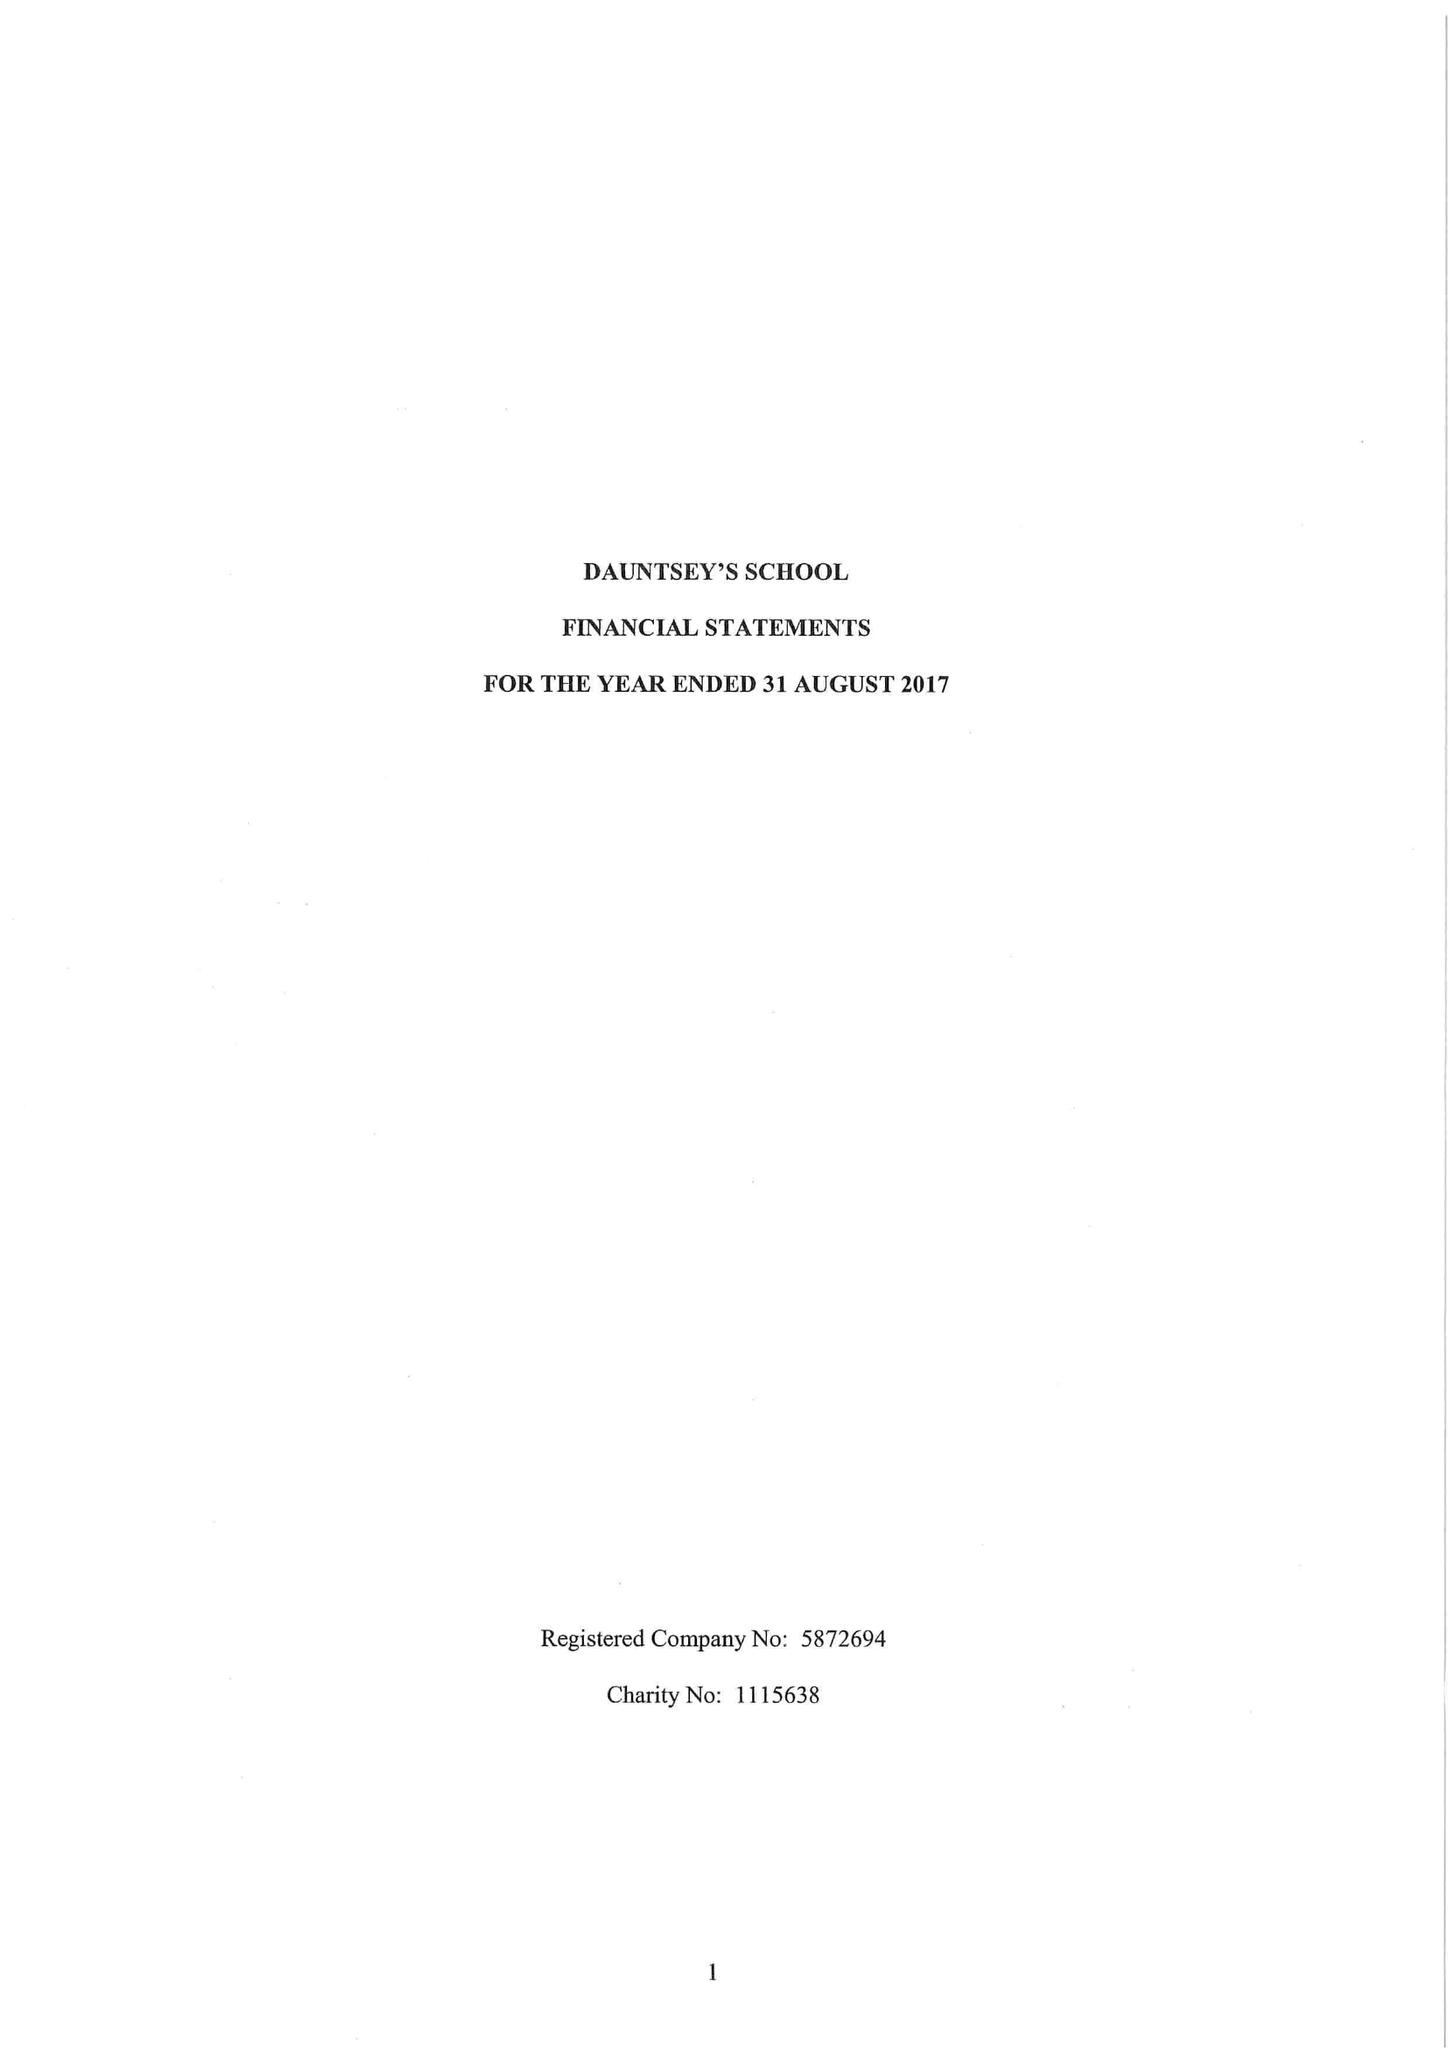What is the value for the charity_number?
Answer the question using a single word or phrase. 1115638 